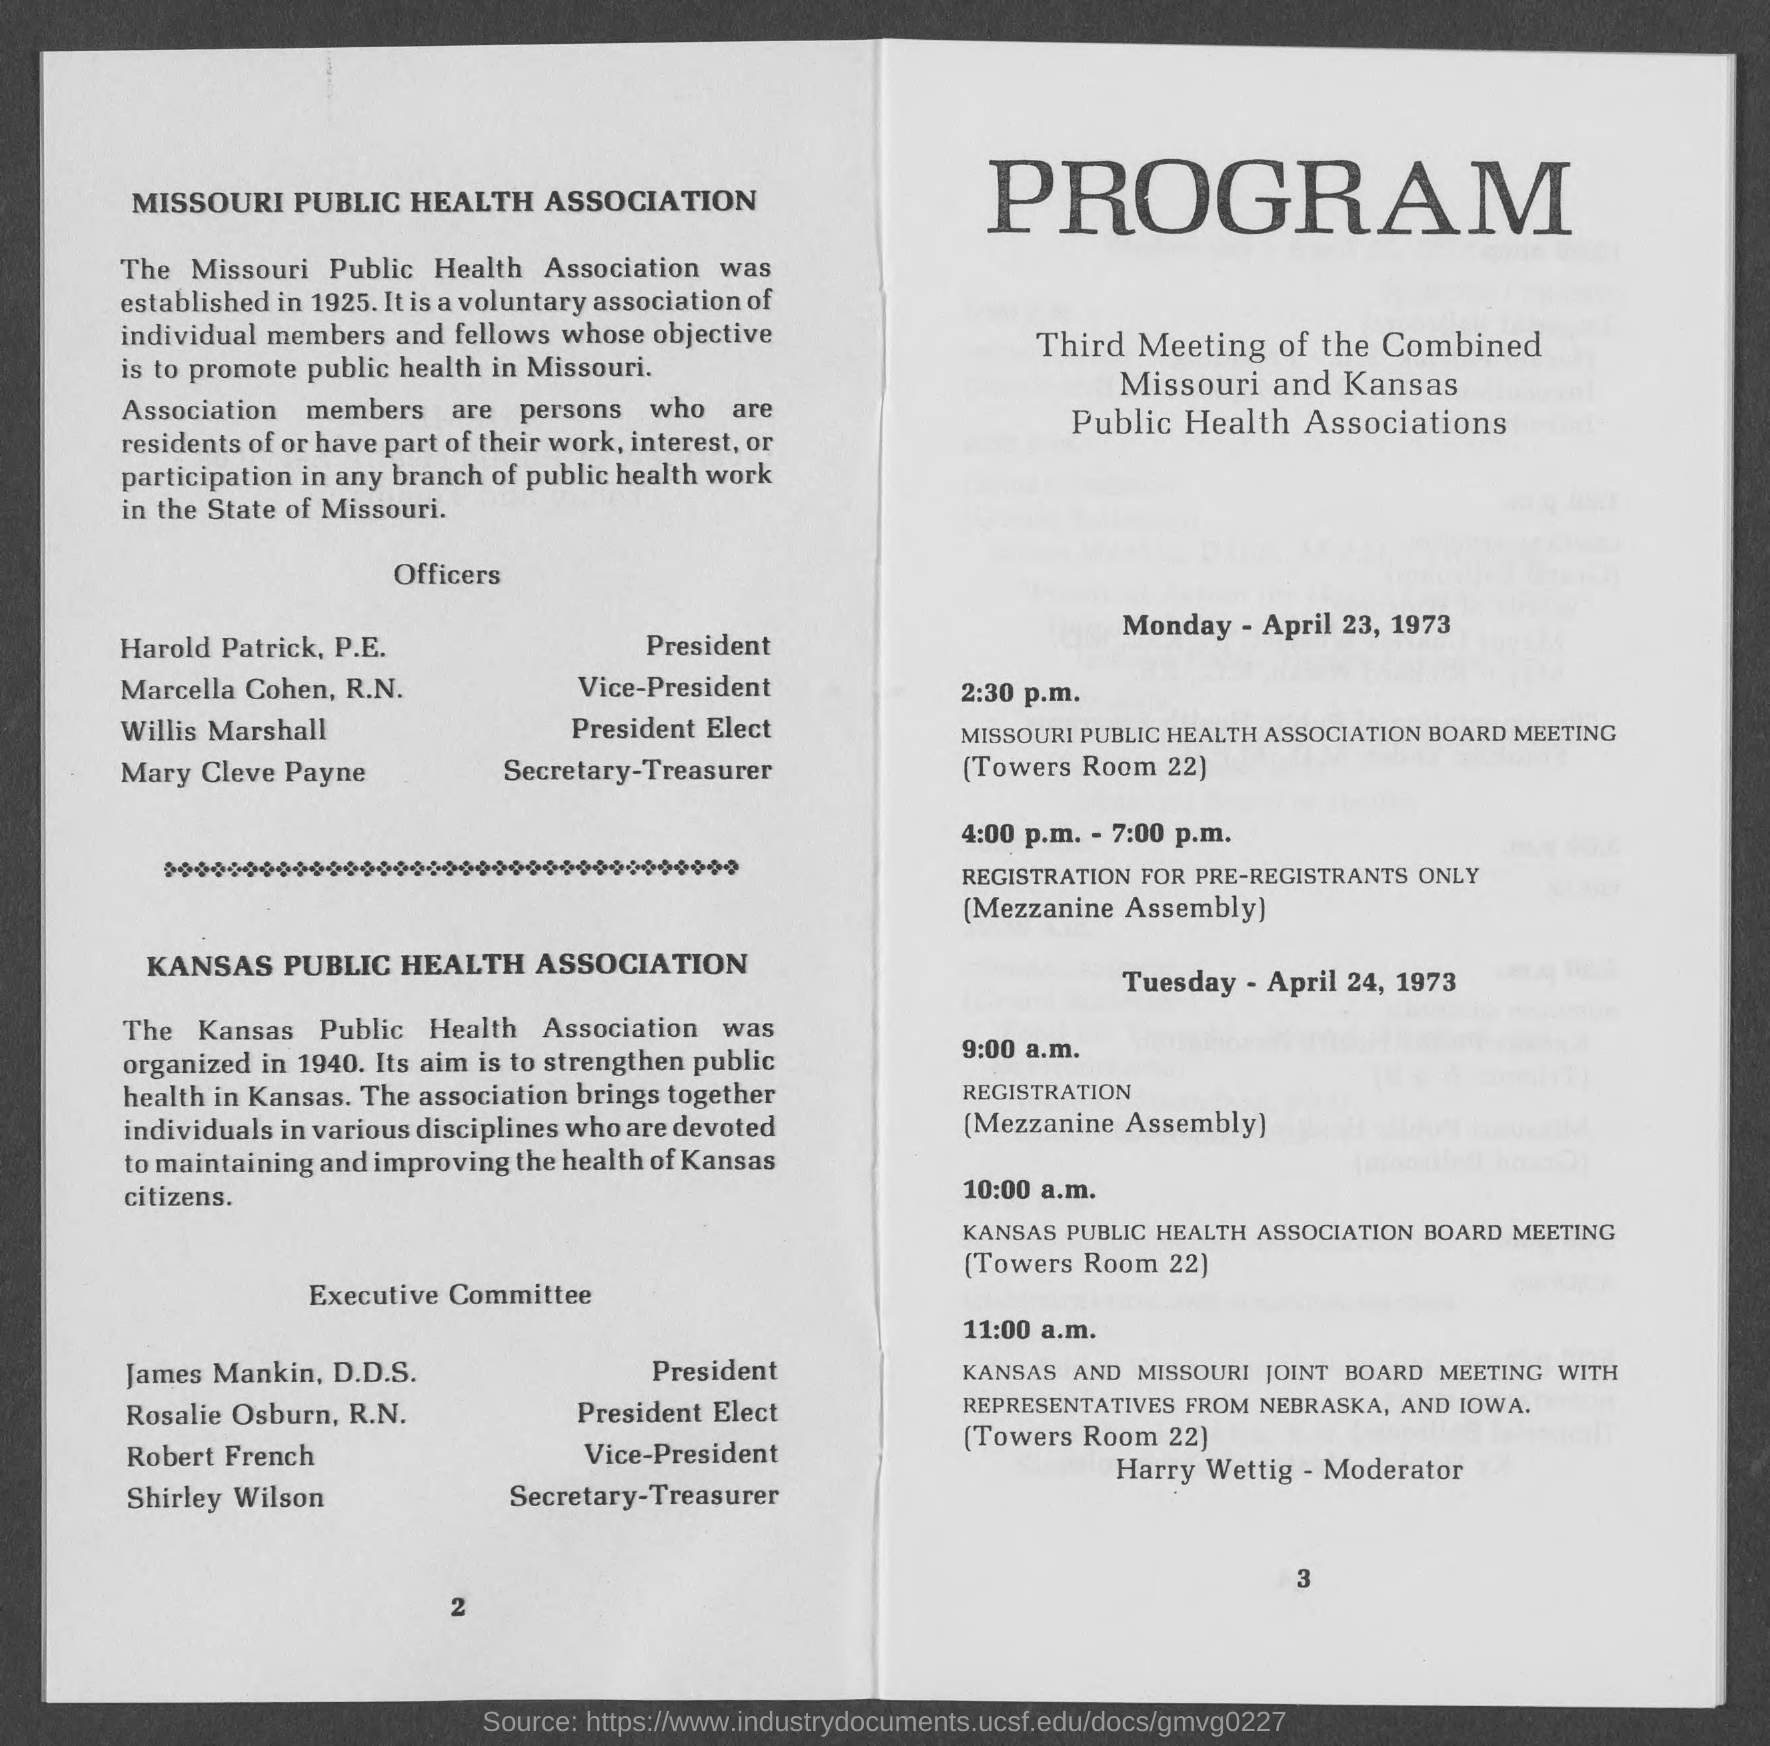Point out several critical features in this image. Marcella Cohen, R.N., is the vice-president of the Missouri Public Health Association. Willis Marshall is the president-elect of the Missouri Public Health Association. The Vice-President of the Kansas Public Health Association is Robert French. The Secretary-Treasurer of the Missouri Public Health Association is Mary Cleve Payne. James Mankin, D.D.S., is the current president of the Kansas Public Health Association. 